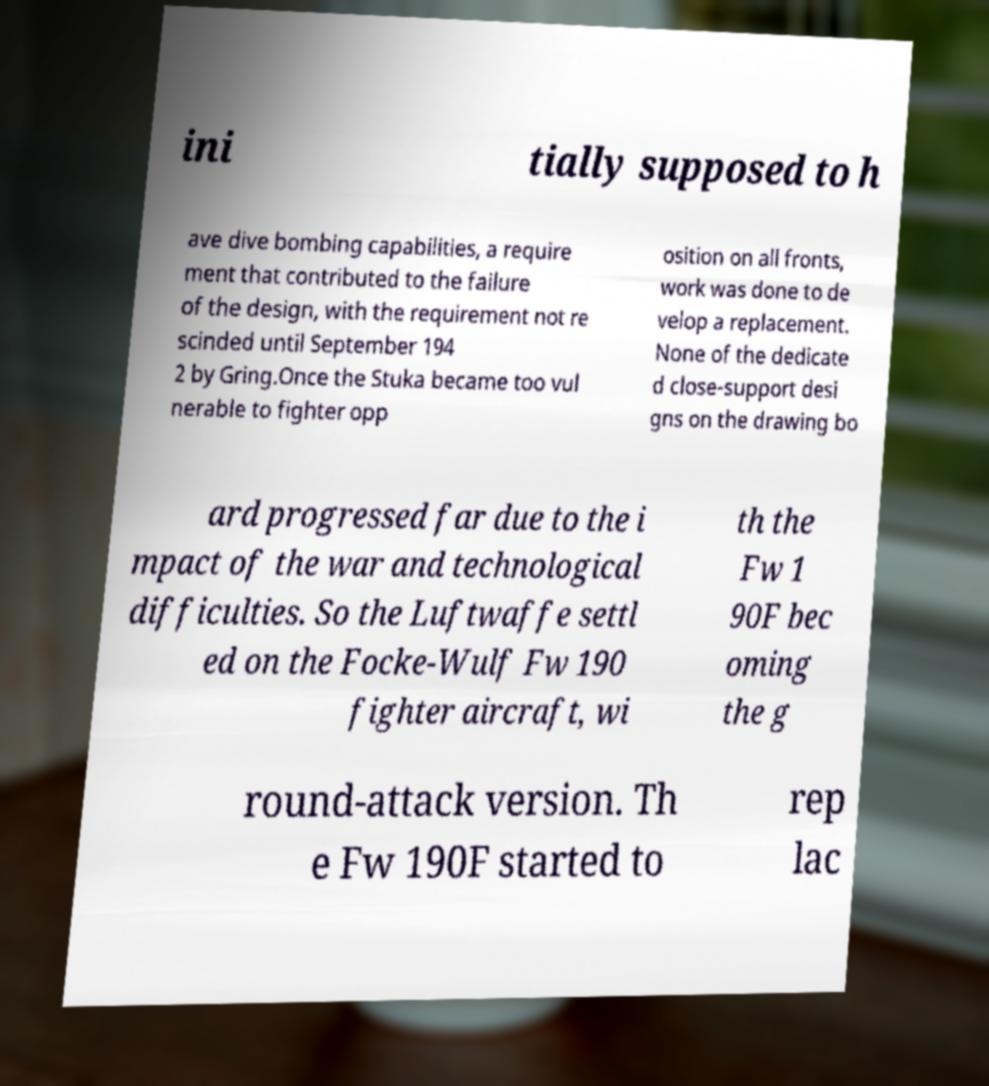Please read and relay the text visible in this image. What does it say? ini tially supposed to h ave dive bombing capabilities, a require ment that contributed to the failure of the design, with the requirement not re scinded until September 194 2 by Gring.Once the Stuka became too vul nerable to fighter opp osition on all fronts, work was done to de velop a replacement. None of the dedicate d close-support desi gns on the drawing bo ard progressed far due to the i mpact of the war and technological difficulties. So the Luftwaffe settl ed on the Focke-Wulf Fw 190 fighter aircraft, wi th the Fw 1 90F bec oming the g round-attack version. Th e Fw 190F started to rep lac 